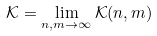Convert formula to latex. <formula><loc_0><loc_0><loc_500><loc_500>\mathcal { K } = \lim _ { n , m \rightarrow \infty } \mathcal { K } ( n , m )</formula> 